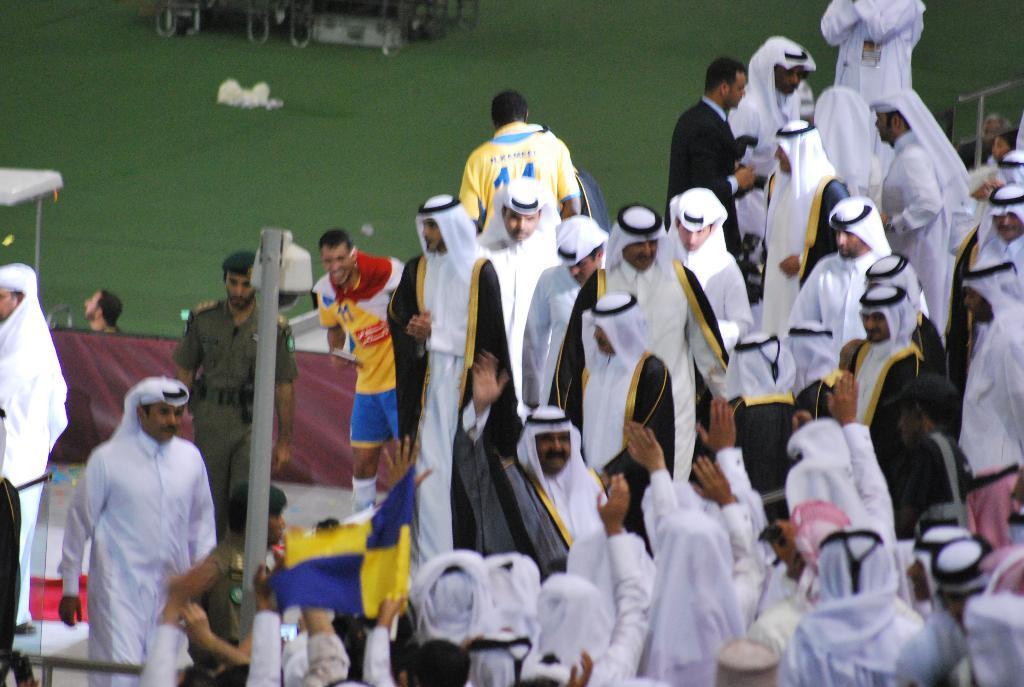Please provide a concise description of this image. In the image there are many arab men standing and walking and on the left side there is grassland. 